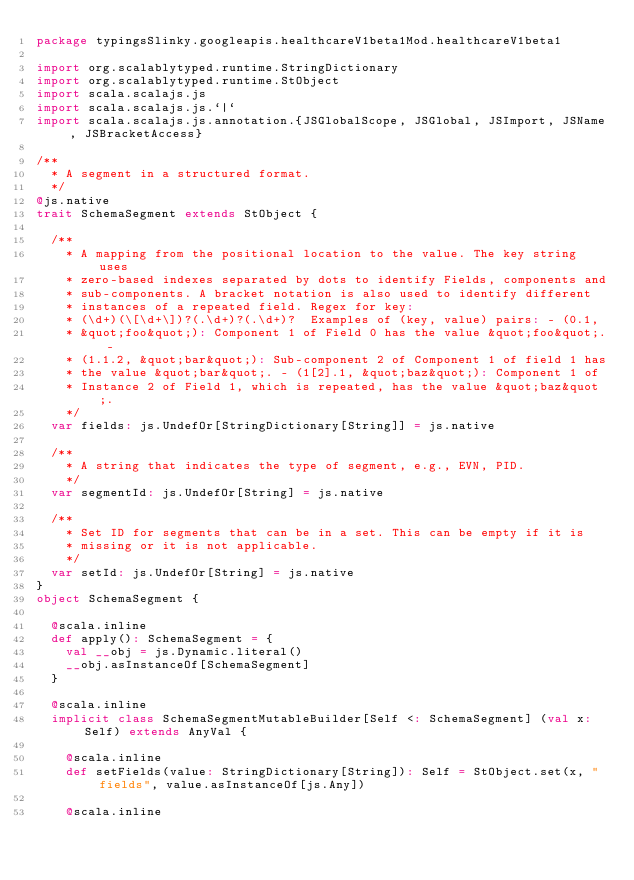Convert code to text. <code><loc_0><loc_0><loc_500><loc_500><_Scala_>package typingsSlinky.googleapis.healthcareV1beta1Mod.healthcareV1beta1

import org.scalablytyped.runtime.StringDictionary
import org.scalablytyped.runtime.StObject
import scala.scalajs.js
import scala.scalajs.js.`|`
import scala.scalajs.js.annotation.{JSGlobalScope, JSGlobal, JSImport, JSName, JSBracketAccess}

/**
  * A segment in a structured format.
  */
@js.native
trait SchemaSegment extends StObject {
  
  /**
    * A mapping from the positional location to the value. The key string uses
    * zero-based indexes separated by dots to identify Fields, components and
    * sub-components. A bracket notation is also used to identify different
    * instances of a repeated field. Regex for key:
    * (\d+)(\[\d+\])?(.\d+)?(.\d+)?  Examples of (key, value) pairs: - (0.1,
    * &quot;foo&quot;): Component 1 of Field 0 has the value &quot;foo&quot;. -
    * (1.1.2, &quot;bar&quot;): Sub-component 2 of Component 1 of field 1 has
    * the value &quot;bar&quot;. - (1[2].1, &quot;baz&quot;): Component 1 of
    * Instance 2 of Field 1, which is repeated, has the value &quot;baz&quot;.
    */
  var fields: js.UndefOr[StringDictionary[String]] = js.native
  
  /**
    * A string that indicates the type of segment, e.g., EVN, PID.
    */
  var segmentId: js.UndefOr[String] = js.native
  
  /**
    * Set ID for segments that can be in a set. This can be empty if it is
    * missing or it is not applicable.
    */
  var setId: js.UndefOr[String] = js.native
}
object SchemaSegment {
  
  @scala.inline
  def apply(): SchemaSegment = {
    val __obj = js.Dynamic.literal()
    __obj.asInstanceOf[SchemaSegment]
  }
  
  @scala.inline
  implicit class SchemaSegmentMutableBuilder[Self <: SchemaSegment] (val x: Self) extends AnyVal {
    
    @scala.inline
    def setFields(value: StringDictionary[String]): Self = StObject.set(x, "fields", value.asInstanceOf[js.Any])
    
    @scala.inline</code> 